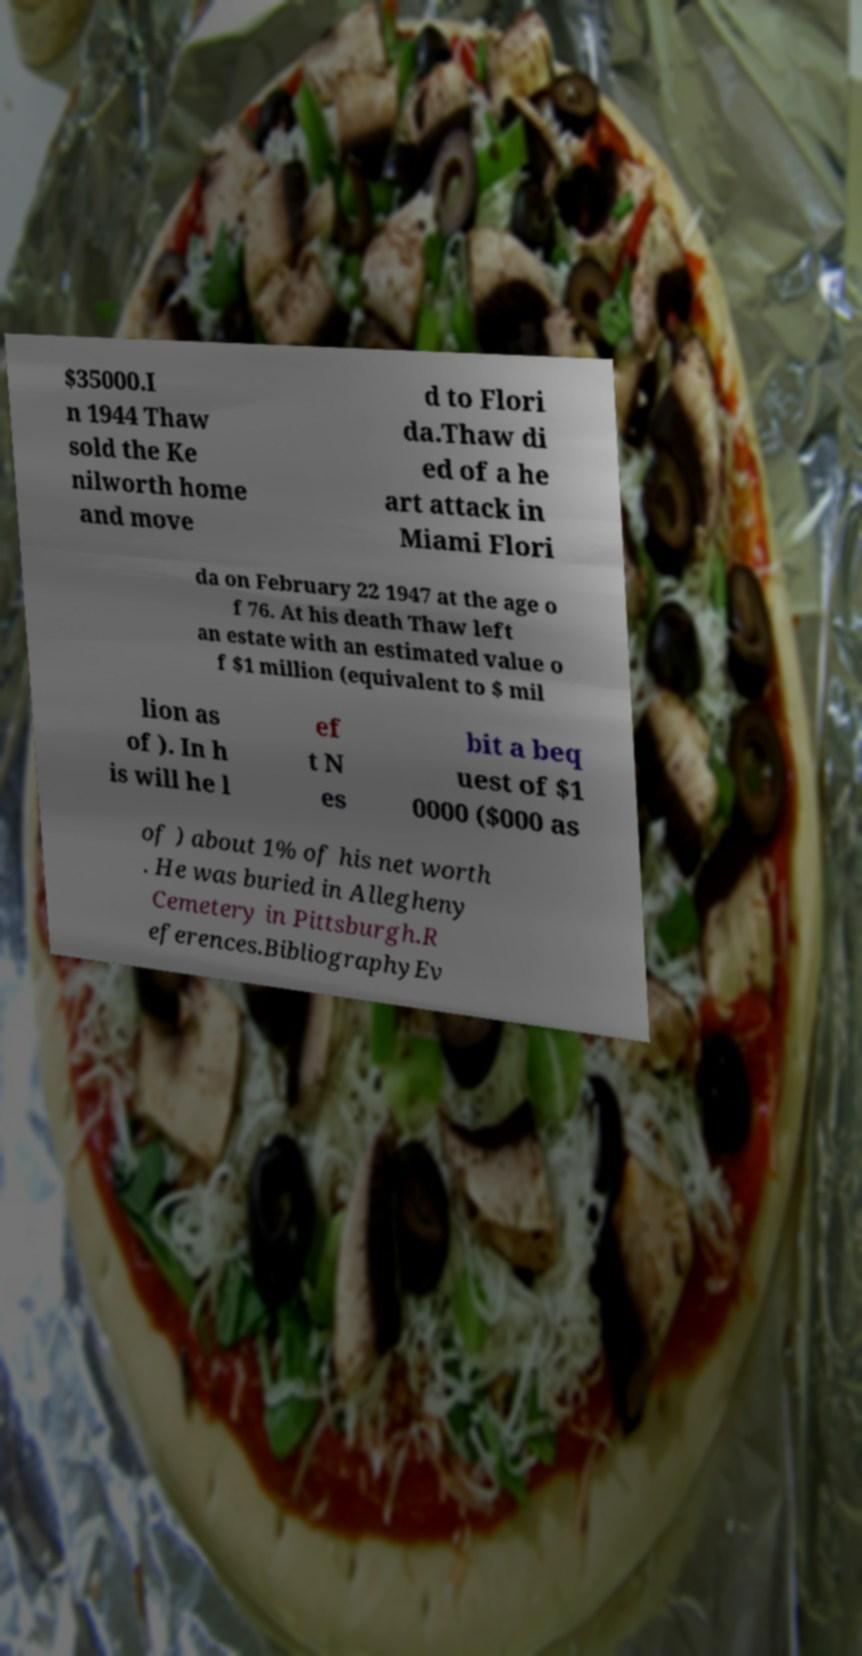Please identify and transcribe the text found in this image. $35000.I n 1944 Thaw sold the Ke nilworth home and move d to Flori da.Thaw di ed of a he art attack in Miami Flori da on February 22 1947 at the age o f 76. At his death Thaw left an estate with an estimated value o f $1 million (equivalent to $ mil lion as of ). In h is will he l ef t N es bit a beq uest of $1 0000 ($000 as of ) about 1% of his net worth . He was buried in Allegheny Cemetery in Pittsburgh.R eferences.BibliographyEv 